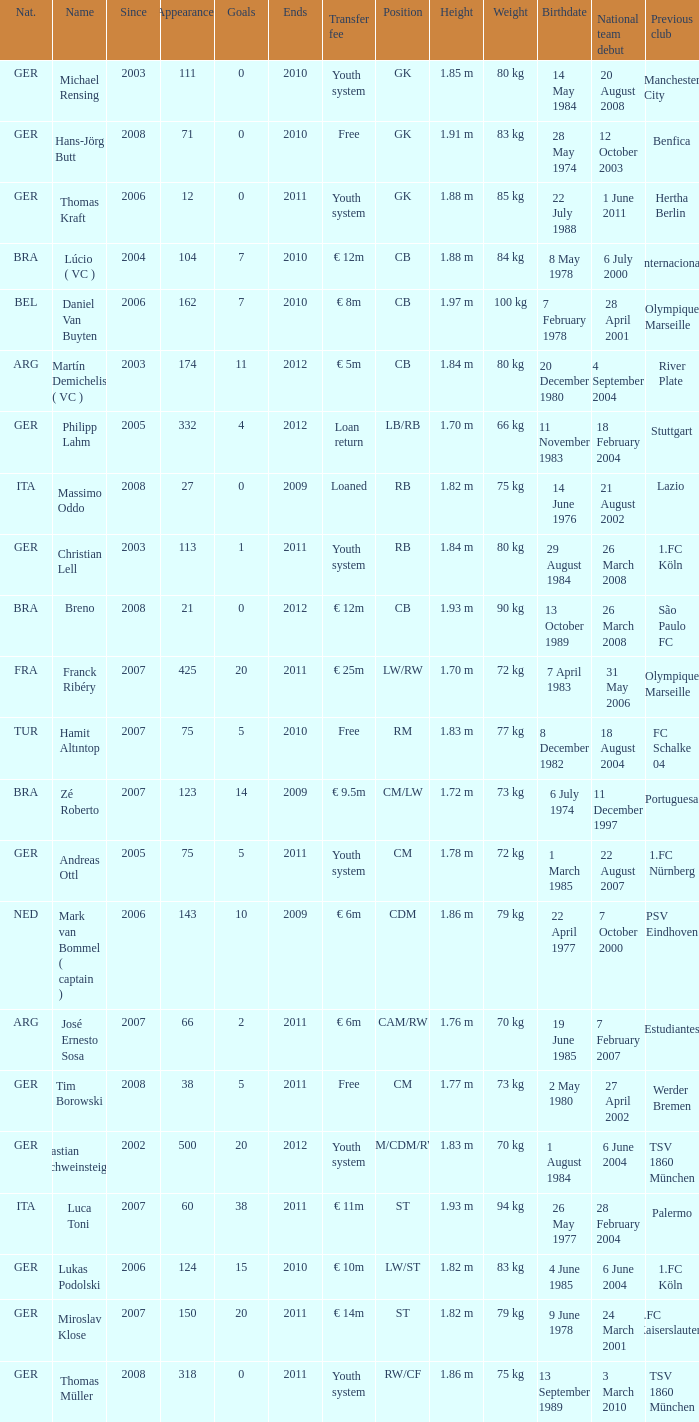What is the lowest year in since that had a transfer fee of € 14m and ended after 2011? None. 